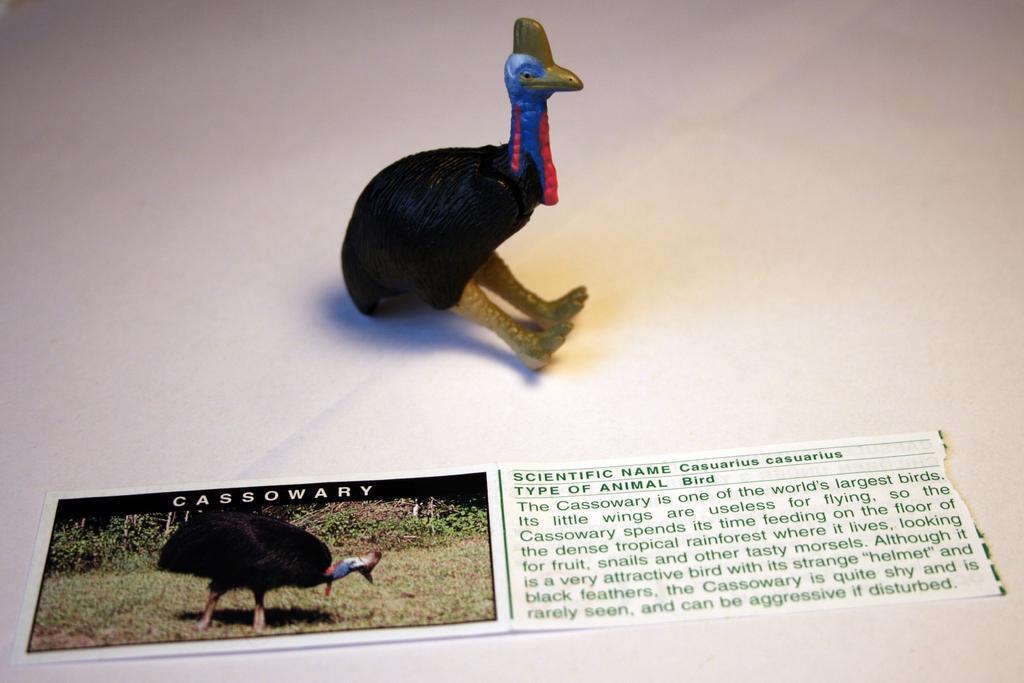Describe this image in one or two sentences. It is a toy of a bird and in front of the toy there is the picture of the bird and some information is written beside the picture. 